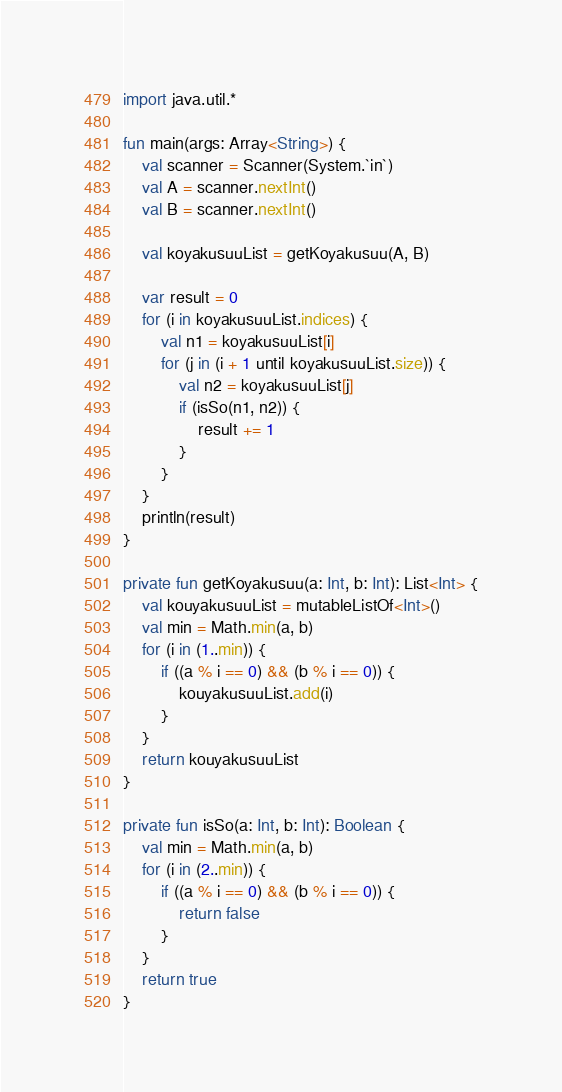Convert code to text. <code><loc_0><loc_0><loc_500><loc_500><_Kotlin_>import java.util.*

fun main(args: Array<String>) {
    val scanner = Scanner(System.`in`)
    val A = scanner.nextInt()
    val B = scanner.nextInt()

    val koyakusuuList = getKoyakusuu(A, B)

    var result = 0
    for (i in koyakusuuList.indices) {
        val n1 = koyakusuuList[i]
        for (j in (i + 1 until koyakusuuList.size)) {
            val n2 = koyakusuuList[j]
            if (isSo(n1, n2)) {
                result += 1
            }
        }
    }
    println(result)
}

private fun getKoyakusuu(a: Int, b: Int): List<Int> {
    val kouyakusuuList = mutableListOf<Int>()
    val min = Math.min(a, b)
    for (i in (1..min)) {
        if ((a % i == 0) && (b % i == 0)) {
            kouyakusuuList.add(i)
        }
    }
    return kouyakusuuList
}

private fun isSo(a: Int, b: Int): Boolean {
    val min = Math.min(a, b)
    for (i in (2..min)) {
        if ((a % i == 0) && (b % i == 0)) {
            return false
        }
    }
    return true
}</code> 